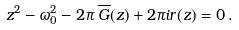Convert formula to latex. <formula><loc_0><loc_0><loc_500><loc_500>z ^ { 2 } - \omega _ { 0 } ^ { 2 } - 2 \pi \, \overline { G } ( z ) + 2 \pi i r ( z ) = 0 \, .</formula> 